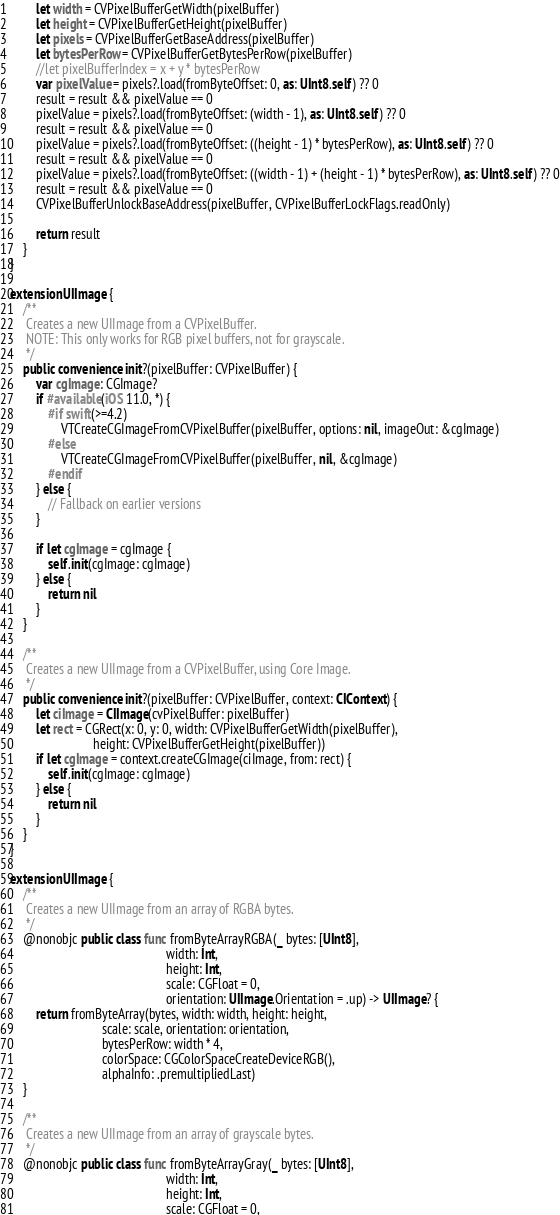Convert code to text. <code><loc_0><loc_0><loc_500><loc_500><_Swift_>        let width = CVPixelBufferGetWidth(pixelBuffer)
        let height = CVPixelBufferGetHeight(pixelBuffer)
        let pixels = CVPixelBufferGetBaseAddress(pixelBuffer)
        let bytesPerRow = CVPixelBufferGetBytesPerRow(pixelBuffer)
        //let pixelBufferIndex = x + y * bytesPerRow
        var pixelValue = pixels?.load(fromByteOffset: 0, as: UInt8.self) ?? 0
        result = result && pixelValue == 0
        pixelValue = pixels?.load(fromByteOffset: (width - 1), as: UInt8.self) ?? 0
        result = result && pixelValue == 0
        pixelValue = pixels?.load(fromByteOffset: ((height - 1) * bytesPerRow), as: UInt8.self) ?? 0
        result = result && pixelValue == 0
        pixelValue = pixels?.load(fromByteOffset: ((width - 1) + (height - 1) * bytesPerRow), as: UInt8.self) ?? 0
        result = result && pixelValue == 0
        CVPixelBufferUnlockBaseAddress(pixelBuffer, CVPixelBufferLockFlags.readOnly)
        
        return result
    }
}

extension UIImage {
    /**
     Creates a new UIImage from a CVPixelBuffer.
     NOTE: This only works for RGB pixel buffers, not for grayscale.
     */
    public convenience init?(pixelBuffer: CVPixelBuffer) {
        var cgImage: CGImage?
        if #available(iOS 11.0, *) {
            #if swift(>=4.2)
                VTCreateCGImageFromCVPixelBuffer(pixelBuffer, options: nil, imageOut: &cgImage)
            #else
                VTCreateCGImageFromCVPixelBuffer(pixelBuffer, nil, &cgImage)
            #endif
        } else {
            // Fallback on earlier versions
        }
        
        if let cgImage = cgImage {
            self.init(cgImage: cgImage)
        } else {
            return nil
        }
    }
    
    /**
     Creates a new UIImage from a CVPixelBuffer, using Core Image.
     */
    public convenience init?(pixelBuffer: CVPixelBuffer, context: CIContext) {
        let ciImage = CIImage(cvPixelBuffer: pixelBuffer)
        let rect = CGRect(x: 0, y: 0, width: CVPixelBufferGetWidth(pixelBuffer),
                          height: CVPixelBufferGetHeight(pixelBuffer))
        if let cgImage = context.createCGImage(ciImage, from: rect) {
            self.init(cgImage: cgImage)
        } else {
            return nil
        }
    }
}

extension UIImage {
    /**
     Creates a new UIImage from an array of RGBA bytes.
     */
    @nonobjc public class func fromByteArrayRGBA(_ bytes: [UInt8],
                                                 width: Int,
                                                 height: Int,
                                                 scale: CGFloat = 0,
                                                 orientation: UIImage.Orientation = .up) -> UIImage? {
        return fromByteArray(bytes, width: width, height: height,
                             scale: scale, orientation: orientation,
                             bytesPerRow: width * 4,
                             colorSpace: CGColorSpaceCreateDeviceRGB(),
                             alphaInfo: .premultipliedLast)
    }
    
    /**
     Creates a new UIImage from an array of grayscale bytes.
     */
    @nonobjc public class func fromByteArrayGray(_ bytes: [UInt8],
                                                 width: Int,
                                                 height: Int,
                                                 scale: CGFloat = 0,</code> 